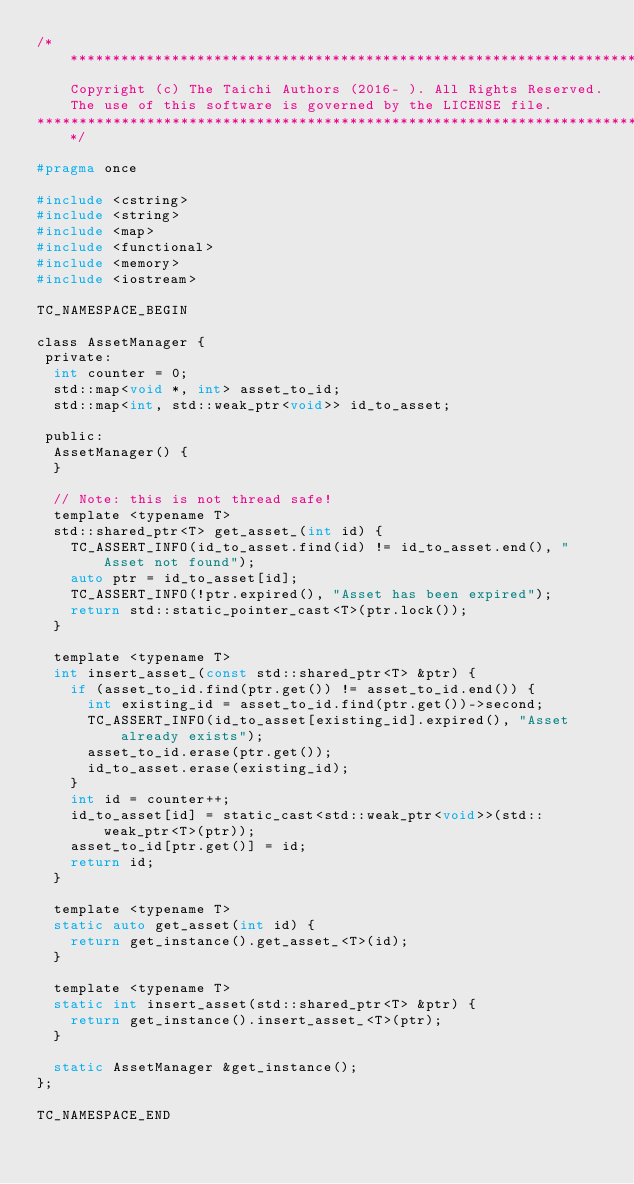<code> <loc_0><loc_0><loc_500><loc_500><_C_>/*******************************************************************************
    Copyright (c) The Taichi Authors (2016- ). All Rights Reserved.
    The use of this software is governed by the LICENSE file.
*******************************************************************************/

#pragma once

#include <cstring>
#include <string>
#include <map>
#include <functional>
#include <memory>
#include <iostream>

TC_NAMESPACE_BEGIN

class AssetManager {
 private:
  int counter = 0;
  std::map<void *, int> asset_to_id;
  std::map<int, std::weak_ptr<void>> id_to_asset;

 public:
  AssetManager() {
  }

  // Note: this is not thread safe!
  template <typename T>
  std::shared_ptr<T> get_asset_(int id) {
    TC_ASSERT_INFO(id_to_asset.find(id) != id_to_asset.end(), "Asset not found");
    auto ptr = id_to_asset[id];
    TC_ASSERT_INFO(!ptr.expired(), "Asset has been expired");
    return std::static_pointer_cast<T>(ptr.lock());
  }

  template <typename T>
  int insert_asset_(const std::shared_ptr<T> &ptr) {
    if (asset_to_id.find(ptr.get()) != asset_to_id.end()) {
      int existing_id = asset_to_id.find(ptr.get())->second;
      TC_ASSERT_INFO(id_to_asset[existing_id].expired(), "Asset already exists");
      asset_to_id.erase(ptr.get());
      id_to_asset.erase(existing_id);
    }
    int id = counter++;
    id_to_asset[id] = static_cast<std::weak_ptr<void>>(std::weak_ptr<T>(ptr));
    asset_to_id[ptr.get()] = id;
    return id;
  }

  template <typename T>
  static auto get_asset(int id) {
    return get_instance().get_asset_<T>(id);
  }

  template <typename T>
  static int insert_asset(std::shared_ptr<T> &ptr) {
    return get_instance().insert_asset_<T>(ptr);
  }

  static AssetManager &get_instance();
};

TC_NAMESPACE_END
</code> 